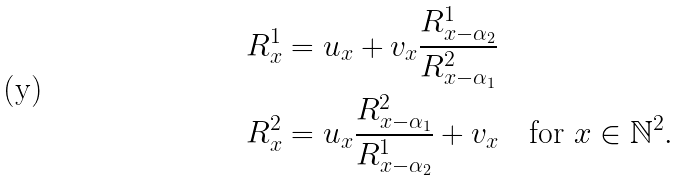<formula> <loc_0><loc_0><loc_500><loc_500>R ^ { 1 } _ { x } & = u _ { x } + v _ { x } \frac { R ^ { 1 } _ { x - \alpha _ { 2 } } } { R ^ { 2 } _ { x - \alpha _ { 1 } } } \\ R ^ { 2 } _ { x } & = u _ { x } \frac { R ^ { 2 } _ { x - \alpha _ { 1 } } } { R ^ { 1 } _ { x - \alpha _ { 2 } } } + v _ { x } \quad \text {for } x \in \mathbb { N } ^ { 2 } .</formula> 